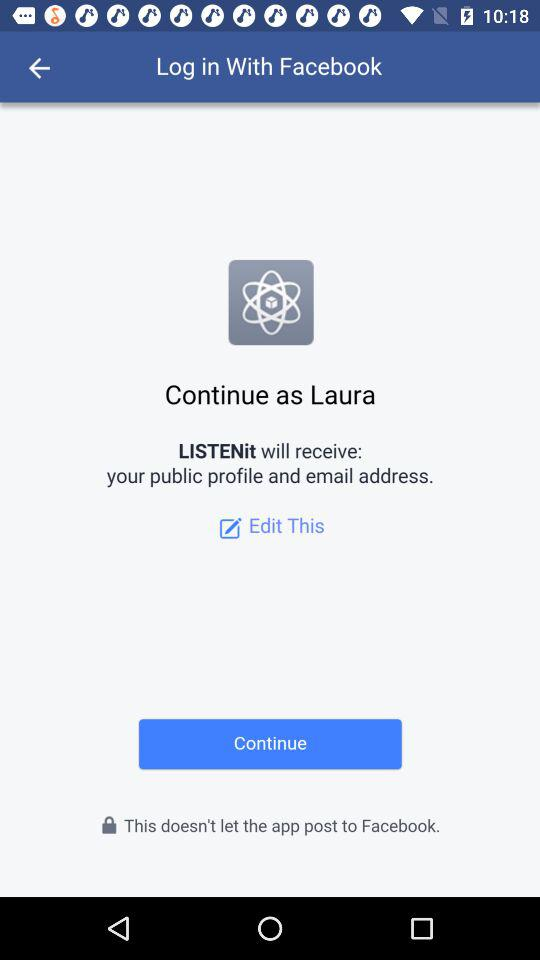What app will receive your email address? The app is "LISTENit". 